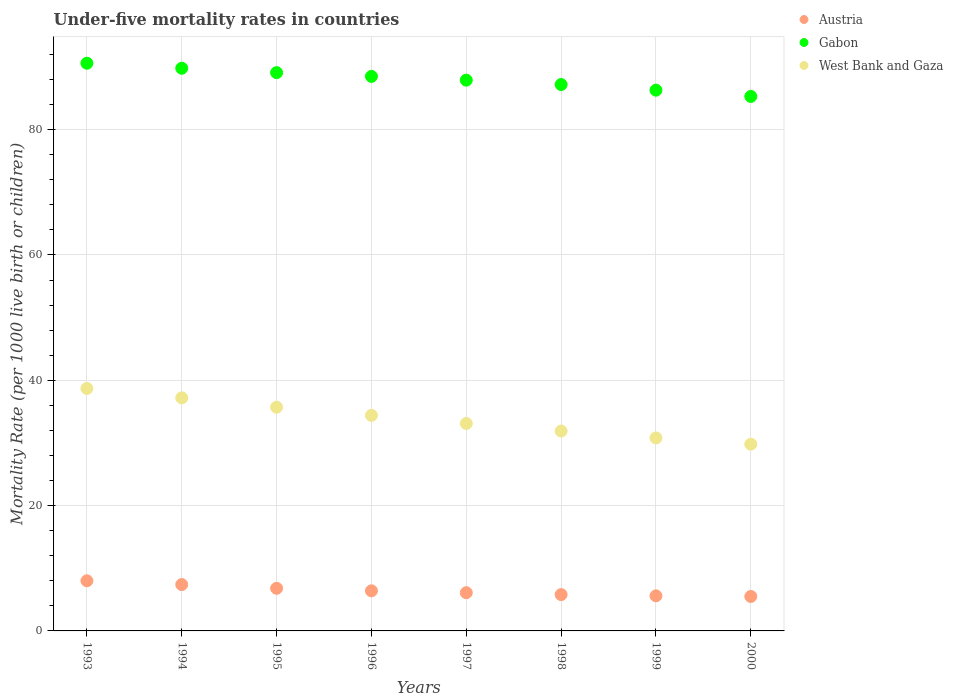How many different coloured dotlines are there?
Provide a succinct answer. 3. What is the under-five mortality rate in Gabon in 1998?
Offer a terse response. 87.2. Across all years, what is the maximum under-five mortality rate in West Bank and Gaza?
Keep it short and to the point. 38.7. Across all years, what is the minimum under-five mortality rate in West Bank and Gaza?
Your answer should be compact. 29.8. In which year was the under-five mortality rate in Austria maximum?
Your answer should be very brief. 1993. In which year was the under-five mortality rate in Austria minimum?
Offer a very short reply. 2000. What is the total under-five mortality rate in Austria in the graph?
Offer a very short reply. 51.6. What is the difference between the under-five mortality rate in West Bank and Gaza in 1994 and that in 2000?
Give a very brief answer. 7.4. What is the difference between the under-five mortality rate in Gabon in 1994 and the under-five mortality rate in Austria in 1999?
Make the answer very short. 84.2. What is the average under-five mortality rate in Austria per year?
Provide a succinct answer. 6.45. In the year 2000, what is the difference between the under-five mortality rate in Austria and under-five mortality rate in West Bank and Gaza?
Provide a succinct answer. -24.3. In how many years, is the under-five mortality rate in Gabon greater than 48?
Give a very brief answer. 8. What is the ratio of the under-five mortality rate in West Bank and Gaza in 1997 to that in 2000?
Keep it short and to the point. 1.11. Is the under-five mortality rate in Gabon in 1993 less than that in 1998?
Offer a very short reply. No. What is the difference between the highest and the second highest under-five mortality rate in West Bank and Gaza?
Your answer should be very brief. 1.5. What is the difference between the highest and the lowest under-five mortality rate in Gabon?
Keep it short and to the point. 5.3. Is it the case that in every year, the sum of the under-five mortality rate in Austria and under-five mortality rate in West Bank and Gaza  is greater than the under-five mortality rate in Gabon?
Provide a short and direct response. No. Does the under-five mortality rate in Gabon monotonically increase over the years?
Offer a terse response. No. Is the under-five mortality rate in Gabon strictly less than the under-five mortality rate in Austria over the years?
Provide a succinct answer. No. How many years are there in the graph?
Your answer should be very brief. 8. Does the graph contain any zero values?
Give a very brief answer. No. Does the graph contain grids?
Offer a very short reply. Yes. Where does the legend appear in the graph?
Provide a succinct answer. Top right. How many legend labels are there?
Your answer should be compact. 3. How are the legend labels stacked?
Give a very brief answer. Vertical. What is the title of the graph?
Keep it short and to the point. Under-five mortality rates in countries. Does "Congo (Republic)" appear as one of the legend labels in the graph?
Keep it short and to the point. No. What is the label or title of the X-axis?
Offer a terse response. Years. What is the label or title of the Y-axis?
Make the answer very short. Mortality Rate (per 1000 live birth or children). What is the Mortality Rate (per 1000 live birth or children) of Gabon in 1993?
Provide a short and direct response. 90.6. What is the Mortality Rate (per 1000 live birth or children) of West Bank and Gaza in 1993?
Offer a very short reply. 38.7. What is the Mortality Rate (per 1000 live birth or children) of Austria in 1994?
Your answer should be very brief. 7.4. What is the Mortality Rate (per 1000 live birth or children) of Gabon in 1994?
Your answer should be very brief. 89.8. What is the Mortality Rate (per 1000 live birth or children) in West Bank and Gaza in 1994?
Provide a short and direct response. 37.2. What is the Mortality Rate (per 1000 live birth or children) in Gabon in 1995?
Your response must be concise. 89.1. What is the Mortality Rate (per 1000 live birth or children) of West Bank and Gaza in 1995?
Provide a succinct answer. 35.7. What is the Mortality Rate (per 1000 live birth or children) of Austria in 1996?
Your answer should be very brief. 6.4. What is the Mortality Rate (per 1000 live birth or children) of Gabon in 1996?
Give a very brief answer. 88.5. What is the Mortality Rate (per 1000 live birth or children) of West Bank and Gaza in 1996?
Offer a very short reply. 34.4. What is the Mortality Rate (per 1000 live birth or children) of Austria in 1997?
Offer a terse response. 6.1. What is the Mortality Rate (per 1000 live birth or children) of Gabon in 1997?
Ensure brevity in your answer.  87.9. What is the Mortality Rate (per 1000 live birth or children) of West Bank and Gaza in 1997?
Give a very brief answer. 33.1. What is the Mortality Rate (per 1000 live birth or children) in Gabon in 1998?
Offer a very short reply. 87.2. What is the Mortality Rate (per 1000 live birth or children) of West Bank and Gaza in 1998?
Your response must be concise. 31.9. What is the Mortality Rate (per 1000 live birth or children) in Gabon in 1999?
Provide a succinct answer. 86.3. What is the Mortality Rate (per 1000 live birth or children) in West Bank and Gaza in 1999?
Keep it short and to the point. 30.8. What is the Mortality Rate (per 1000 live birth or children) in Gabon in 2000?
Make the answer very short. 85.3. What is the Mortality Rate (per 1000 live birth or children) in West Bank and Gaza in 2000?
Your answer should be compact. 29.8. Across all years, what is the maximum Mortality Rate (per 1000 live birth or children) of Austria?
Your answer should be very brief. 8. Across all years, what is the maximum Mortality Rate (per 1000 live birth or children) of Gabon?
Your response must be concise. 90.6. Across all years, what is the maximum Mortality Rate (per 1000 live birth or children) in West Bank and Gaza?
Offer a terse response. 38.7. Across all years, what is the minimum Mortality Rate (per 1000 live birth or children) of Austria?
Provide a succinct answer. 5.5. Across all years, what is the minimum Mortality Rate (per 1000 live birth or children) in Gabon?
Keep it short and to the point. 85.3. Across all years, what is the minimum Mortality Rate (per 1000 live birth or children) in West Bank and Gaza?
Ensure brevity in your answer.  29.8. What is the total Mortality Rate (per 1000 live birth or children) in Austria in the graph?
Keep it short and to the point. 51.6. What is the total Mortality Rate (per 1000 live birth or children) of Gabon in the graph?
Your response must be concise. 704.7. What is the total Mortality Rate (per 1000 live birth or children) in West Bank and Gaza in the graph?
Your answer should be very brief. 271.6. What is the difference between the Mortality Rate (per 1000 live birth or children) of Austria in 1993 and that in 1994?
Give a very brief answer. 0.6. What is the difference between the Mortality Rate (per 1000 live birth or children) in Gabon in 1993 and that in 1994?
Keep it short and to the point. 0.8. What is the difference between the Mortality Rate (per 1000 live birth or children) of West Bank and Gaza in 1993 and that in 1994?
Give a very brief answer. 1.5. What is the difference between the Mortality Rate (per 1000 live birth or children) of Austria in 1993 and that in 1995?
Provide a succinct answer. 1.2. What is the difference between the Mortality Rate (per 1000 live birth or children) in Gabon in 1993 and that in 1995?
Your answer should be very brief. 1.5. What is the difference between the Mortality Rate (per 1000 live birth or children) of Austria in 1993 and that in 1996?
Give a very brief answer. 1.6. What is the difference between the Mortality Rate (per 1000 live birth or children) in West Bank and Gaza in 1993 and that in 1996?
Your answer should be very brief. 4.3. What is the difference between the Mortality Rate (per 1000 live birth or children) in Austria in 1993 and that in 1997?
Make the answer very short. 1.9. What is the difference between the Mortality Rate (per 1000 live birth or children) of West Bank and Gaza in 1993 and that in 1997?
Make the answer very short. 5.6. What is the difference between the Mortality Rate (per 1000 live birth or children) in Austria in 1993 and that in 1998?
Give a very brief answer. 2.2. What is the difference between the Mortality Rate (per 1000 live birth or children) of West Bank and Gaza in 1993 and that in 1998?
Make the answer very short. 6.8. What is the difference between the Mortality Rate (per 1000 live birth or children) of Austria in 1993 and that in 1999?
Your answer should be very brief. 2.4. What is the difference between the Mortality Rate (per 1000 live birth or children) of Gabon in 1993 and that in 1999?
Make the answer very short. 4.3. What is the difference between the Mortality Rate (per 1000 live birth or children) in West Bank and Gaza in 1993 and that in 1999?
Provide a short and direct response. 7.9. What is the difference between the Mortality Rate (per 1000 live birth or children) in Austria in 1993 and that in 2000?
Offer a very short reply. 2.5. What is the difference between the Mortality Rate (per 1000 live birth or children) in Gabon in 1993 and that in 2000?
Make the answer very short. 5.3. What is the difference between the Mortality Rate (per 1000 live birth or children) of West Bank and Gaza in 1993 and that in 2000?
Offer a very short reply. 8.9. What is the difference between the Mortality Rate (per 1000 live birth or children) of Austria in 1994 and that in 1995?
Make the answer very short. 0.6. What is the difference between the Mortality Rate (per 1000 live birth or children) in Gabon in 1994 and that in 1995?
Ensure brevity in your answer.  0.7. What is the difference between the Mortality Rate (per 1000 live birth or children) of Gabon in 1994 and that in 1997?
Keep it short and to the point. 1.9. What is the difference between the Mortality Rate (per 1000 live birth or children) in West Bank and Gaza in 1994 and that in 1997?
Give a very brief answer. 4.1. What is the difference between the Mortality Rate (per 1000 live birth or children) of Gabon in 1994 and that in 1998?
Give a very brief answer. 2.6. What is the difference between the Mortality Rate (per 1000 live birth or children) of West Bank and Gaza in 1994 and that in 1999?
Your response must be concise. 6.4. What is the difference between the Mortality Rate (per 1000 live birth or children) in Gabon in 1994 and that in 2000?
Your answer should be very brief. 4.5. What is the difference between the Mortality Rate (per 1000 live birth or children) of West Bank and Gaza in 1994 and that in 2000?
Give a very brief answer. 7.4. What is the difference between the Mortality Rate (per 1000 live birth or children) in Austria in 1995 and that in 1996?
Your answer should be compact. 0.4. What is the difference between the Mortality Rate (per 1000 live birth or children) of Gabon in 1995 and that in 1996?
Your answer should be very brief. 0.6. What is the difference between the Mortality Rate (per 1000 live birth or children) of West Bank and Gaza in 1995 and that in 1997?
Your response must be concise. 2.6. What is the difference between the Mortality Rate (per 1000 live birth or children) in Gabon in 1995 and that in 1999?
Keep it short and to the point. 2.8. What is the difference between the Mortality Rate (per 1000 live birth or children) in Austria in 1995 and that in 2000?
Your response must be concise. 1.3. What is the difference between the Mortality Rate (per 1000 live birth or children) of West Bank and Gaza in 1995 and that in 2000?
Your answer should be compact. 5.9. What is the difference between the Mortality Rate (per 1000 live birth or children) of Austria in 1996 and that in 1997?
Ensure brevity in your answer.  0.3. What is the difference between the Mortality Rate (per 1000 live birth or children) of Austria in 1996 and that in 1998?
Give a very brief answer. 0.6. What is the difference between the Mortality Rate (per 1000 live birth or children) in Gabon in 1996 and that in 1998?
Your response must be concise. 1.3. What is the difference between the Mortality Rate (per 1000 live birth or children) of Austria in 1996 and that in 1999?
Offer a very short reply. 0.8. What is the difference between the Mortality Rate (per 1000 live birth or children) in West Bank and Gaza in 1996 and that in 1999?
Ensure brevity in your answer.  3.6. What is the difference between the Mortality Rate (per 1000 live birth or children) in Austria in 1996 and that in 2000?
Your answer should be very brief. 0.9. What is the difference between the Mortality Rate (per 1000 live birth or children) of Gabon in 1996 and that in 2000?
Your answer should be compact. 3.2. What is the difference between the Mortality Rate (per 1000 live birth or children) in West Bank and Gaza in 1996 and that in 2000?
Ensure brevity in your answer.  4.6. What is the difference between the Mortality Rate (per 1000 live birth or children) of Gabon in 1997 and that in 1998?
Provide a succinct answer. 0.7. What is the difference between the Mortality Rate (per 1000 live birth or children) of Austria in 1997 and that in 2000?
Provide a short and direct response. 0.6. What is the difference between the Mortality Rate (per 1000 live birth or children) in Gabon in 1998 and that in 1999?
Make the answer very short. 0.9. What is the difference between the Mortality Rate (per 1000 live birth or children) of Gabon in 1998 and that in 2000?
Provide a succinct answer. 1.9. What is the difference between the Mortality Rate (per 1000 live birth or children) of West Bank and Gaza in 1998 and that in 2000?
Offer a very short reply. 2.1. What is the difference between the Mortality Rate (per 1000 live birth or children) of Austria in 1999 and that in 2000?
Keep it short and to the point. 0.1. What is the difference between the Mortality Rate (per 1000 live birth or children) in Gabon in 1999 and that in 2000?
Your answer should be compact. 1. What is the difference between the Mortality Rate (per 1000 live birth or children) in Austria in 1993 and the Mortality Rate (per 1000 live birth or children) in Gabon in 1994?
Your answer should be compact. -81.8. What is the difference between the Mortality Rate (per 1000 live birth or children) in Austria in 1993 and the Mortality Rate (per 1000 live birth or children) in West Bank and Gaza in 1994?
Your answer should be compact. -29.2. What is the difference between the Mortality Rate (per 1000 live birth or children) in Gabon in 1993 and the Mortality Rate (per 1000 live birth or children) in West Bank and Gaza in 1994?
Give a very brief answer. 53.4. What is the difference between the Mortality Rate (per 1000 live birth or children) in Austria in 1993 and the Mortality Rate (per 1000 live birth or children) in Gabon in 1995?
Provide a short and direct response. -81.1. What is the difference between the Mortality Rate (per 1000 live birth or children) in Austria in 1993 and the Mortality Rate (per 1000 live birth or children) in West Bank and Gaza in 1995?
Keep it short and to the point. -27.7. What is the difference between the Mortality Rate (per 1000 live birth or children) of Gabon in 1993 and the Mortality Rate (per 1000 live birth or children) of West Bank and Gaza in 1995?
Offer a terse response. 54.9. What is the difference between the Mortality Rate (per 1000 live birth or children) in Austria in 1993 and the Mortality Rate (per 1000 live birth or children) in Gabon in 1996?
Give a very brief answer. -80.5. What is the difference between the Mortality Rate (per 1000 live birth or children) in Austria in 1993 and the Mortality Rate (per 1000 live birth or children) in West Bank and Gaza in 1996?
Offer a very short reply. -26.4. What is the difference between the Mortality Rate (per 1000 live birth or children) of Gabon in 1993 and the Mortality Rate (per 1000 live birth or children) of West Bank and Gaza in 1996?
Provide a short and direct response. 56.2. What is the difference between the Mortality Rate (per 1000 live birth or children) in Austria in 1993 and the Mortality Rate (per 1000 live birth or children) in Gabon in 1997?
Your answer should be very brief. -79.9. What is the difference between the Mortality Rate (per 1000 live birth or children) in Austria in 1993 and the Mortality Rate (per 1000 live birth or children) in West Bank and Gaza in 1997?
Offer a very short reply. -25.1. What is the difference between the Mortality Rate (per 1000 live birth or children) of Gabon in 1993 and the Mortality Rate (per 1000 live birth or children) of West Bank and Gaza in 1997?
Keep it short and to the point. 57.5. What is the difference between the Mortality Rate (per 1000 live birth or children) in Austria in 1993 and the Mortality Rate (per 1000 live birth or children) in Gabon in 1998?
Make the answer very short. -79.2. What is the difference between the Mortality Rate (per 1000 live birth or children) in Austria in 1993 and the Mortality Rate (per 1000 live birth or children) in West Bank and Gaza in 1998?
Your answer should be compact. -23.9. What is the difference between the Mortality Rate (per 1000 live birth or children) in Gabon in 1993 and the Mortality Rate (per 1000 live birth or children) in West Bank and Gaza in 1998?
Give a very brief answer. 58.7. What is the difference between the Mortality Rate (per 1000 live birth or children) of Austria in 1993 and the Mortality Rate (per 1000 live birth or children) of Gabon in 1999?
Keep it short and to the point. -78.3. What is the difference between the Mortality Rate (per 1000 live birth or children) of Austria in 1993 and the Mortality Rate (per 1000 live birth or children) of West Bank and Gaza in 1999?
Keep it short and to the point. -22.8. What is the difference between the Mortality Rate (per 1000 live birth or children) of Gabon in 1993 and the Mortality Rate (per 1000 live birth or children) of West Bank and Gaza in 1999?
Offer a very short reply. 59.8. What is the difference between the Mortality Rate (per 1000 live birth or children) in Austria in 1993 and the Mortality Rate (per 1000 live birth or children) in Gabon in 2000?
Make the answer very short. -77.3. What is the difference between the Mortality Rate (per 1000 live birth or children) of Austria in 1993 and the Mortality Rate (per 1000 live birth or children) of West Bank and Gaza in 2000?
Your answer should be very brief. -21.8. What is the difference between the Mortality Rate (per 1000 live birth or children) of Gabon in 1993 and the Mortality Rate (per 1000 live birth or children) of West Bank and Gaza in 2000?
Make the answer very short. 60.8. What is the difference between the Mortality Rate (per 1000 live birth or children) in Austria in 1994 and the Mortality Rate (per 1000 live birth or children) in Gabon in 1995?
Your response must be concise. -81.7. What is the difference between the Mortality Rate (per 1000 live birth or children) of Austria in 1994 and the Mortality Rate (per 1000 live birth or children) of West Bank and Gaza in 1995?
Ensure brevity in your answer.  -28.3. What is the difference between the Mortality Rate (per 1000 live birth or children) of Gabon in 1994 and the Mortality Rate (per 1000 live birth or children) of West Bank and Gaza in 1995?
Keep it short and to the point. 54.1. What is the difference between the Mortality Rate (per 1000 live birth or children) of Austria in 1994 and the Mortality Rate (per 1000 live birth or children) of Gabon in 1996?
Your response must be concise. -81.1. What is the difference between the Mortality Rate (per 1000 live birth or children) of Austria in 1994 and the Mortality Rate (per 1000 live birth or children) of West Bank and Gaza in 1996?
Provide a short and direct response. -27. What is the difference between the Mortality Rate (per 1000 live birth or children) of Gabon in 1994 and the Mortality Rate (per 1000 live birth or children) of West Bank and Gaza in 1996?
Offer a very short reply. 55.4. What is the difference between the Mortality Rate (per 1000 live birth or children) of Austria in 1994 and the Mortality Rate (per 1000 live birth or children) of Gabon in 1997?
Provide a succinct answer. -80.5. What is the difference between the Mortality Rate (per 1000 live birth or children) of Austria in 1994 and the Mortality Rate (per 1000 live birth or children) of West Bank and Gaza in 1997?
Offer a very short reply. -25.7. What is the difference between the Mortality Rate (per 1000 live birth or children) in Gabon in 1994 and the Mortality Rate (per 1000 live birth or children) in West Bank and Gaza in 1997?
Offer a terse response. 56.7. What is the difference between the Mortality Rate (per 1000 live birth or children) in Austria in 1994 and the Mortality Rate (per 1000 live birth or children) in Gabon in 1998?
Provide a succinct answer. -79.8. What is the difference between the Mortality Rate (per 1000 live birth or children) in Austria in 1994 and the Mortality Rate (per 1000 live birth or children) in West Bank and Gaza in 1998?
Keep it short and to the point. -24.5. What is the difference between the Mortality Rate (per 1000 live birth or children) of Gabon in 1994 and the Mortality Rate (per 1000 live birth or children) of West Bank and Gaza in 1998?
Your answer should be very brief. 57.9. What is the difference between the Mortality Rate (per 1000 live birth or children) of Austria in 1994 and the Mortality Rate (per 1000 live birth or children) of Gabon in 1999?
Your answer should be very brief. -78.9. What is the difference between the Mortality Rate (per 1000 live birth or children) in Austria in 1994 and the Mortality Rate (per 1000 live birth or children) in West Bank and Gaza in 1999?
Your response must be concise. -23.4. What is the difference between the Mortality Rate (per 1000 live birth or children) of Gabon in 1994 and the Mortality Rate (per 1000 live birth or children) of West Bank and Gaza in 1999?
Your answer should be very brief. 59. What is the difference between the Mortality Rate (per 1000 live birth or children) of Austria in 1994 and the Mortality Rate (per 1000 live birth or children) of Gabon in 2000?
Your response must be concise. -77.9. What is the difference between the Mortality Rate (per 1000 live birth or children) of Austria in 1994 and the Mortality Rate (per 1000 live birth or children) of West Bank and Gaza in 2000?
Your response must be concise. -22.4. What is the difference between the Mortality Rate (per 1000 live birth or children) of Gabon in 1994 and the Mortality Rate (per 1000 live birth or children) of West Bank and Gaza in 2000?
Your answer should be very brief. 60. What is the difference between the Mortality Rate (per 1000 live birth or children) in Austria in 1995 and the Mortality Rate (per 1000 live birth or children) in Gabon in 1996?
Your answer should be compact. -81.7. What is the difference between the Mortality Rate (per 1000 live birth or children) in Austria in 1995 and the Mortality Rate (per 1000 live birth or children) in West Bank and Gaza in 1996?
Provide a succinct answer. -27.6. What is the difference between the Mortality Rate (per 1000 live birth or children) of Gabon in 1995 and the Mortality Rate (per 1000 live birth or children) of West Bank and Gaza in 1996?
Provide a short and direct response. 54.7. What is the difference between the Mortality Rate (per 1000 live birth or children) of Austria in 1995 and the Mortality Rate (per 1000 live birth or children) of Gabon in 1997?
Provide a succinct answer. -81.1. What is the difference between the Mortality Rate (per 1000 live birth or children) in Austria in 1995 and the Mortality Rate (per 1000 live birth or children) in West Bank and Gaza in 1997?
Your answer should be compact. -26.3. What is the difference between the Mortality Rate (per 1000 live birth or children) in Gabon in 1995 and the Mortality Rate (per 1000 live birth or children) in West Bank and Gaza in 1997?
Your answer should be compact. 56. What is the difference between the Mortality Rate (per 1000 live birth or children) of Austria in 1995 and the Mortality Rate (per 1000 live birth or children) of Gabon in 1998?
Give a very brief answer. -80.4. What is the difference between the Mortality Rate (per 1000 live birth or children) in Austria in 1995 and the Mortality Rate (per 1000 live birth or children) in West Bank and Gaza in 1998?
Keep it short and to the point. -25.1. What is the difference between the Mortality Rate (per 1000 live birth or children) of Gabon in 1995 and the Mortality Rate (per 1000 live birth or children) of West Bank and Gaza in 1998?
Your response must be concise. 57.2. What is the difference between the Mortality Rate (per 1000 live birth or children) of Austria in 1995 and the Mortality Rate (per 1000 live birth or children) of Gabon in 1999?
Offer a very short reply. -79.5. What is the difference between the Mortality Rate (per 1000 live birth or children) of Gabon in 1995 and the Mortality Rate (per 1000 live birth or children) of West Bank and Gaza in 1999?
Your answer should be compact. 58.3. What is the difference between the Mortality Rate (per 1000 live birth or children) of Austria in 1995 and the Mortality Rate (per 1000 live birth or children) of Gabon in 2000?
Your answer should be very brief. -78.5. What is the difference between the Mortality Rate (per 1000 live birth or children) of Gabon in 1995 and the Mortality Rate (per 1000 live birth or children) of West Bank and Gaza in 2000?
Provide a short and direct response. 59.3. What is the difference between the Mortality Rate (per 1000 live birth or children) of Austria in 1996 and the Mortality Rate (per 1000 live birth or children) of Gabon in 1997?
Make the answer very short. -81.5. What is the difference between the Mortality Rate (per 1000 live birth or children) in Austria in 1996 and the Mortality Rate (per 1000 live birth or children) in West Bank and Gaza in 1997?
Give a very brief answer. -26.7. What is the difference between the Mortality Rate (per 1000 live birth or children) in Gabon in 1996 and the Mortality Rate (per 1000 live birth or children) in West Bank and Gaza in 1997?
Provide a succinct answer. 55.4. What is the difference between the Mortality Rate (per 1000 live birth or children) of Austria in 1996 and the Mortality Rate (per 1000 live birth or children) of Gabon in 1998?
Your answer should be very brief. -80.8. What is the difference between the Mortality Rate (per 1000 live birth or children) of Austria in 1996 and the Mortality Rate (per 1000 live birth or children) of West Bank and Gaza in 1998?
Give a very brief answer. -25.5. What is the difference between the Mortality Rate (per 1000 live birth or children) in Gabon in 1996 and the Mortality Rate (per 1000 live birth or children) in West Bank and Gaza in 1998?
Your answer should be compact. 56.6. What is the difference between the Mortality Rate (per 1000 live birth or children) of Austria in 1996 and the Mortality Rate (per 1000 live birth or children) of Gabon in 1999?
Your answer should be very brief. -79.9. What is the difference between the Mortality Rate (per 1000 live birth or children) in Austria in 1996 and the Mortality Rate (per 1000 live birth or children) in West Bank and Gaza in 1999?
Keep it short and to the point. -24.4. What is the difference between the Mortality Rate (per 1000 live birth or children) in Gabon in 1996 and the Mortality Rate (per 1000 live birth or children) in West Bank and Gaza in 1999?
Provide a short and direct response. 57.7. What is the difference between the Mortality Rate (per 1000 live birth or children) of Austria in 1996 and the Mortality Rate (per 1000 live birth or children) of Gabon in 2000?
Make the answer very short. -78.9. What is the difference between the Mortality Rate (per 1000 live birth or children) in Austria in 1996 and the Mortality Rate (per 1000 live birth or children) in West Bank and Gaza in 2000?
Make the answer very short. -23.4. What is the difference between the Mortality Rate (per 1000 live birth or children) of Gabon in 1996 and the Mortality Rate (per 1000 live birth or children) of West Bank and Gaza in 2000?
Provide a short and direct response. 58.7. What is the difference between the Mortality Rate (per 1000 live birth or children) of Austria in 1997 and the Mortality Rate (per 1000 live birth or children) of Gabon in 1998?
Offer a very short reply. -81.1. What is the difference between the Mortality Rate (per 1000 live birth or children) of Austria in 1997 and the Mortality Rate (per 1000 live birth or children) of West Bank and Gaza in 1998?
Offer a terse response. -25.8. What is the difference between the Mortality Rate (per 1000 live birth or children) in Gabon in 1997 and the Mortality Rate (per 1000 live birth or children) in West Bank and Gaza in 1998?
Make the answer very short. 56. What is the difference between the Mortality Rate (per 1000 live birth or children) in Austria in 1997 and the Mortality Rate (per 1000 live birth or children) in Gabon in 1999?
Offer a very short reply. -80.2. What is the difference between the Mortality Rate (per 1000 live birth or children) in Austria in 1997 and the Mortality Rate (per 1000 live birth or children) in West Bank and Gaza in 1999?
Make the answer very short. -24.7. What is the difference between the Mortality Rate (per 1000 live birth or children) in Gabon in 1997 and the Mortality Rate (per 1000 live birth or children) in West Bank and Gaza in 1999?
Keep it short and to the point. 57.1. What is the difference between the Mortality Rate (per 1000 live birth or children) of Austria in 1997 and the Mortality Rate (per 1000 live birth or children) of Gabon in 2000?
Make the answer very short. -79.2. What is the difference between the Mortality Rate (per 1000 live birth or children) of Austria in 1997 and the Mortality Rate (per 1000 live birth or children) of West Bank and Gaza in 2000?
Make the answer very short. -23.7. What is the difference between the Mortality Rate (per 1000 live birth or children) in Gabon in 1997 and the Mortality Rate (per 1000 live birth or children) in West Bank and Gaza in 2000?
Your response must be concise. 58.1. What is the difference between the Mortality Rate (per 1000 live birth or children) of Austria in 1998 and the Mortality Rate (per 1000 live birth or children) of Gabon in 1999?
Give a very brief answer. -80.5. What is the difference between the Mortality Rate (per 1000 live birth or children) in Gabon in 1998 and the Mortality Rate (per 1000 live birth or children) in West Bank and Gaza in 1999?
Offer a terse response. 56.4. What is the difference between the Mortality Rate (per 1000 live birth or children) in Austria in 1998 and the Mortality Rate (per 1000 live birth or children) in Gabon in 2000?
Offer a terse response. -79.5. What is the difference between the Mortality Rate (per 1000 live birth or children) in Gabon in 1998 and the Mortality Rate (per 1000 live birth or children) in West Bank and Gaza in 2000?
Give a very brief answer. 57.4. What is the difference between the Mortality Rate (per 1000 live birth or children) in Austria in 1999 and the Mortality Rate (per 1000 live birth or children) in Gabon in 2000?
Keep it short and to the point. -79.7. What is the difference between the Mortality Rate (per 1000 live birth or children) in Austria in 1999 and the Mortality Rate (per 1000 live birth or children) in West Bank and Gaza in 2000?
Provide a short and direct response. -24.2. What is the difference between the Mortality Rate (per 1000 live birth or children) of Gabon in 1999 and the Mortality Rate (per 1000 live birth or children) of West Bank and Gaza in 2000?
Your answer should be compact. 56.5. What is the average Mortality Rate (per 1000 live birth or children) in Austria per year?
Ensure brevity in your answer.  6.45. What is the average Mortality Rate (per 1000 live birth or children) of Gabon per year?
Make the answer very short. 88.09. What is the average Mortality Rate (per 1000 live birth or children) of West Bank and Gaza per year?
Offer a terse response. 33.95. In the year 1993, what is the difference between the Mortality Rate (per 1000 live birth or children) of Austria and Mortality Rate (per 1000 live birth or children) of Gabon?
Ensure brevity in your answer.  -82.6. In the year 1993, what is the difference between the Mortality Rate (per 1000 live birth or children) of Austria and Mortality Rate (per 1000 live birth or children) of West Bank and Gaza?
Make the answer very short. -30.7. In the year 1993, what is the difference between the Mortality Rate (per 1000 live birth or children) in Gabon and Mortality Rate (per 1000 live birth or children) in West Bank and Gaza?
Provide a succinct answer. 51.9. In the year 1994, what is the difference between the Mortality Rate (per 1000 live birth or children) of Austria and Mortality Rate (per 1000 live birth or children) of Gabon?
Offer a very short reply. -82.4. In the year 1994, what is the difference between the Mortality Rate (per 1000 live birth or children) in Austria and Mortality Rate (per 1000 live birth or children) in West Bank and Gaza?
Offer a very short reply. -29.8. In the year 1994, what is the difference between the Mortality Rate (per 1000 live birth or children) of Gabon and Mortality Rate (per 1000 live birth or children) of West Bank and Gaza?
Your answer should be very brief. 52.6. In the year 1995, what is the difference between the Mortality Rate (per 1000 live birth or children) in Austria and Mortality Rate (per 1000 live birth or children) in Gabon?
Your answer should be very brief. -82.3. In the year 1995, what is the difference between the Mortality Rate (per 1000 live birth or children) of Austria and Mortality Rate (per 1000 live birth or children) of West Bank and Gaza?
Your answer should be compact. -28.9. In the year 1995, what is the difference between the Mortality Rate (per 1000 live birth or children) in Gabon and Mortality Rate (per 1000 live birth or children) in West Bank and Gaza?
Your answer should be very brief. 53.4. In the year 1996, what is the difference between the Mortality Rate (per 1000 live birth or children) of Austria and Mortality Rate (per 1000 live birth or children) of Gabon?
Your answer should be compact. -82.1. In the year 1996, what is the difference between the Mortality Rate (per 1000 live birth or children) of Austria and Mortality Rate (per 1000 live birth or children) of West Bank and Gaza?
Make the answer very short. -28. In the year 1996, what is the difference between the Mortality Rate (per 1000 live birth or children) in Gabon and Mortality Rate (per 1000 live birth or children) in West Bank and Gaza?
Provide a short and direct response. 54.1. In the year 1997, what is the difference between the Mortality Rate (per 1000 live birth or children) in Austria and Mortality Rate (per 1000 live birth or children) in Gabon?
Make the answer very short. -81.8. In the year 1997, what is the difference between the Mortality Rate (per 1000 live birth or children) in Gabon and Mortality Rate (per 1000 live birth or children) in West Bank and Gaza?
Make the answer very short. 54.8. In the year 1998, what is the difference between the Mortality Rate (per 1000 live birth or children) of Austria and Mortality Rate (per 1000 live birth or children) of Gabon?
Provide a short and direct response. -81.4. In the year 1998, what is the difference between the Mortality Rate (per 1000 live birth or children) in Austria and Mortality Rate (per 1000 live birth or children) in West Bank and Gaza?
Provide a succinct answer. -26.1. In the year 1998, what is the difference between the Mortality Rate (per 1000 live birth or children) in Gabon and Mortality Rate (per 1000 live birth or children) in West Bank and Gaza?
Make the answer very short. 55.3. In the year 1999, what is the difference between the Mortality Rate (per 1000 live birth or children) in Austria and Mortality Rate (per 1000 live birth or children) in Gabon?
Make the answer very short. -80.7. In the year 1999, what is the difference between the Mortality Rate (per 1000 live birth or children) of Austria and Mortality Rate (per 1000 live birth or children) of West Bank and Gaza?
Keep it short and to the point. -25.2. In the year 1999, what is the difference between the Mortality Rate (per 1000 live birth or children) in Gabon and Mortality Rate (per 1000 live birth or children) in West Bank and Gaza?
Ensure brevity in your answer.  55.5. In the year 2000, what is the difference between the Mortality Rate (per 1000 live birth or children) in Austria and Mortality Rate (per 1000 live birth or children) in Gabon?
Your answer should be compact. -79.8. In the year 2000, what is the difference between the Mortality Rate (per 1000 live birth or children) in Austria and Mortality Rate (per 1000 live birth or children) in West Bank and Gaza?
Your answer should be compact. -24.3. In the year 2000, what is the difference between the Mortality Rate (per 1000 live birth or children) in Gabon and Mortality Rate (per 1000 live birth or children) in West Bank and Gaza?
Your answer should be very brief. 55.5. What is the ratio of the Mortality Rate (per 1000 live birth or children) of Austria in 1993 to that in 1994?
Give a very brief answer. 1.08. What is the ratio of the Mortality Rate (per 1000 live birth or children) of Gabon in 1993 to that in 1994?
Provide a succinct answer. 1.01. What is the ratio of the Mortality Rate (per 1000 live birth or children) of West Bank and Gaza in 1993 to that in 1994?
Keep it short and to the point. 1.04. What is the ratio of the Mortality Rate (per 1000 live birth or children) of Austria in 1993 to that in 1995?
Keep it short and to the point. 1.18. What is the ratio of the Mortality Rate (per 1000 live birth or children) in Gabon in 1993 to that in 1995?
Offer a terse response. 1.02. What is the ratio of the Mortality Rate (per 1000 live birth or children) of West Bank and Gaza in 1993 to that in 1995?
Provide a succinct answer. 1.08. What is the ratio of the Mortality Rate (per 1000 live birth or children) in Austria in 1993 to that in 1996?
Your answer should be very brief. 1.25. What is the ratio of the Mortality Rate (per 1000 live birth or children) of Gabon in 1993 to that in 1996?
Offer a very short reply. 1.02. What is the ratio of the Mortality Rate (per 1000 live birth or children) in West Bank and Gaza in 1993 to that in 1996?
Offer a terse response. 1.12. What is the ratio of the Mortality Rate (per 1000 live birth or children) in Austria in 1993 to that in 1997?
Ensure brevity in your answer.  1.31. What is the ratio of the Mortality Rate (per 1000 live birth or children) in Gabon in 1993 to that in 1997?
Your response must be concise. 1.03. What is the ratio of the Mortality Rate (per 1000 live birth or children) of West Bank and Gaza in 1993 to that in 1997?
Your response must be concise. 1.17. What is the ratio of the Mortality Rate (per 1000 live birth or children) of Austria in 1993 to that in 1998?
Keep it short and to the point. 1.38. What is the ratio of the Mortality Rate (per 1000 live birth or children) in Gabon in 1993 to that in 1998?
Your answer should be very brief. 1.04. What is the ratio of the Mortality Rate (per 1000 live birth or children) in West Bank and Gaza in 1993 to that in 1998?
Offer a terse response. 1.21. What is the ratio of the Mortality Rate (per 1000 live birth or children) of Austria in 1993 to that in 1999?
Your answer should be compact. 1.43. What is the ratio of the Mortality Rate (per 1000 live birth or children) in Gabon in 1993 to that in 1999?
Give a very brief answer. 1.05. What is the ratio of the Mortality Rate (per 1000 live birth or children) of West Bank and Gaza in 1993 to that in 1999?
Offer a very short reply. 1.26. What is the ratio of the Mortality Rate (per 1000 live birth or children) of Austria in 1993 to that in 2000?
Keep it short and to the point. 1.45. What is the ratio of the Mortality Rate (per 1000 live birth or children) in Gabon in 1993 to that in 2000?
Give a very brief answer. 1.06. What is the ratio of the Mortality Rate (per 1000 live birth or children) in West Bank and Gaza in 1993 to that in 2000?
Your answer should be very brief. 1.3. What is the ratio of the Mortality Rate (per 1000 live birth or children) of Austria in 1994 to that in 1995?
Make the answer very short. 1.09. What is the ratio of the Mortality Rate (per 1000 live birth or children) in Gabon in 1994 to that in 1995?
Your answer should be compact. 1.01. What is the ratio of the Mortality Rate (per 1000 live birth or children) of West Bank and Gaza in 1994 to that in 1995?
Offer a terse response. 1.04. What is the ratio of the Mortality Rate (per 1000 live birth or children) of Austria in 1994 to that in 1996?
Ensure brevity in your answer.  1.16. What is the ratio of the Mortality Rate (per 1000 live birth or children) of Gabon in 1994 to that in 1996?
Provide a short and direct response. 1.01. What is the ratio of the Mortality Rate (per 1000 live birth or children) of West Bank and Gaza in 1994 to that in 1996?
Your answer should be compact. 1.08. What is the ratio of the Mortality Rate (per 1000 live birth or children) of Austria in 1994 to that in 1997?
Your answer should be very brief. 1.21. What is the ratio of the Mortality Rate (per 1000 live birth or children) of Gabon in 1994 to that in 1997?
Your answer should be compact. 1.02. What is the ratio of the Mortality Rate (per 1000 live birth or children) of West Bank and Gaza in 1994 to that in 1997?
Keep it short and to the point. 1.12. What is the ratio of the Mortality Rate (per 1000 live birth or children) in Austria in 1994 to that in 1998?
Keep it short and to the point. 1.28. What is the ratio of the Mortality Rate (per 1000 live birth or children) of Gabon in 1994 to that in 1998?
Your answer should be very brief. 1.03. What is the ratio of the Mortality Rate (per 1000 live birth or children) of West Bank and Gaza in 1994 to that in 1998?
Give a very brief answer. 1.17. What is the ratio of the Mortality Rate (per 1000 live birth or children) of Austria in 1994 to that in 1999?
Keep it short and to the point. 1.32. What is the ratio of the Mortality Rate (per 1000 live birth or children) of Gabon in 1994 to that in 1999?
Your answer should be compact. 1.04. What is the ratio of the Mortality Rate (per 1000 live birth or children) in West Bank and Gaza in 1994 to that in 1999?
Provide a succinct answer. 1.21. What is the ratio of the Mortality Rate (per 1000 live birth or children) in Austria in 1994 to that in 2000?
Give a very brief answer. 1.35. What is the ratio of the Mortality Rate (per 1000 live birth or children) of Gabon in 1994 to that in 2000?
Keep it short and to the point. 1.05. What is the ratio of the Mortality Rate (per 1000 live birth or children) in West Bank and Gaza in 1994 to that in 2000?
Your response must be concise. 1.25. What is the ratio of the Mortality Rate (per 1000 live birth or children) of Austria in 1995 to that in 1996?
Provide a short and direct response. 1.06. What is the ratio of the Mortality Rate (per 1000 live birth or children) of Gabon in 1995 to that in 1996?
Give a very brief answer. 1.01. What is the ratio of the Mortality Rate (per 1000 live birth or children) in West Bank and Gaza in 1995 to that in 1996?
Give a very brief answer. 1.04. What is the ratio of the Mortality Rate (per 1000 live birth or children) of Austria in 1995 to that in 1997?
Your response must be concise. 1.11. What is the ratio of the Mortality Rate (per 1000 live birth or children) in Gabon in 1995 to that in 1997?
Ensure brevity in your answer.  1.01. What is the ratio of the Mortality Rate (per 1000 live birth or children) of West Bank and Gaza in 1995 to that in 1997?
Give a very brief answer. 1.08. What is the ratio of the Mortality Rate (per 1000 live birth or children) in Austria in 1995 to that in 1998?
Ensure brevity in your answer.  1.17. What is the ratio of the Mortality Rate (per 1000 live birth or children) in Gabon in 1995 to that in 1998?
Offer a terse response. 1.02. What is the ratio of the Mortality Rate (per 1000 live birth or children) in West Bank and Gaza in 1995 to that in 1998?
Provide a short and direct response. 1.12. What is the ratio of the Mortality Rate (per 1000 live birth or children) of Austria in 1995 to that in 1999?
Provide a short and direct response. 1.21. What is the ratio of the Mortality Rate (per 1000 live birth or children) of Gabon in 1995 to that in 1999?
Your answer should be compact. 1.03. What is the ratio of the Mortality Rate (per 1000 live birth or children) of West Bank and Gaza in 1995 to that in 1999?
Your answer should be compact. 1.16. What is the ratio of the Mortality Rate (per 1000 live birth or children) in Austria in 1995 to that in 2000?
Give a very brief answer. 1.24. What is the ratio of the Mortality Rate (per 1000 live birth or children) of Gabon in 1995 to that in 2000?
Keep it short and to the point. 1.04. What is the ratio of the Mortality Rate (per 1000 live birth or children) in West Bank and Gaza in 1995 to that in 2000?
Give a very brief answer. 1.2. What is the ratio of the Mortality Rate (per 1000 live birth or children) of Austria in 1996 to that in 1997?
Offer a very short reply. 1.05. What is the ratio of the Mortality Rate (per 1000 live birth or children) of Gabon in 1996 to that in 1997?
Provide a succinct answer. 1.01. What is the ratio of the Mortality Rate (per 1000 live birth or children) in West Bank and Gaza in 1996 to that in 1997?
Your answer should be compact. 1.04. What is the ratio of the Mortality Rate (per 1000 live birth or children) in Austria in 1996 to that in 1998?
Your answer should be very brief. 1.1. What is the ratio of the Mortality Rate (per 1000 live birth or children) of Gabon in 1996 to that in 1998?
Ensure brevity in your answer.  1.01. What is the ratio of the Mortality Rate (per 1000 live birth or children) in West Bank and Gaza in 1996 to that in 1998?
Offer a very short reply. 1.08. What is the ratio of the Mortality Rate (per 1000 live birth or children) of Gabon in 1996 to that in 1999?
Keep it short and to the point. 1.03. What is the ratio of the Mortality Rate (per 1000 live birth or children) of West Bank and Gaza in 1996 to that in 1999?
Offer a very short reply. 1.12. What is the ratio of the Mortality Rate (per 1000 live birth or children) of Austria in 1996 to that in 2000?
Your answer should be very brief. 1.16. What is the ratio of the Mortality Rate (per 1000 live birth or children) in Gabon in 1996 to that in 2000?
Ensure brevity in your answer.  1.04. What is the ratio of the Mortality Rate (per 1000 live birth or children) of West Bank and Gaza in 1996 to that in 2000?
Make the answer very short. 1.15. What is the ratio of the Mortality Rate (per 1000 live birth or children) in Austria in 1997 to that in 1998?
Give a very brief answer. 1.05. What is the ratio of the Mortality Rate (per 1000 live birth or children) of Gabon in 1997 to that in 1998?
Provide a succinct answer. 1.01. What is the ratio of the Mortality Rate (per 1000 live birth or children) in West Bank and Gaza in 1997 to that in 1998?
Offer a terse response. 1.04. What is the ratio of the Mortality Rate (per 1000 live birth or children) in Austria in 1997 to that in 1999?
Your answer should be very brief. 1.09. What is the ratio of the Mortality Rate (per 1000 live birth or children) of Gabon in 1997 to that in 1999?
Keep it short and to the point. 1.02. What is the ratio of the Mortality Rate (per 1000 live birth or children) in West Bank and Gaza in 1997 to that in 1999?
Offer a very short reply. 1.07. What is the ratio of the Mortality Rate (per 1000 live birth or children) of Austria in 1997 to that in 2000?
Your response must be concise. 1.11. What is the ratio of the Mortality Rate (per 1000 live birth or children) of Gabon in 1997 to that in 2000?
Give a very brief answer. 1.03. What is the ratio of the Mortality Rate (per 1000 live birth or children) in West Bank and Gaza in 1997 to that in 2000?
Offer a terse response. 1.11. What is the ratio of the Mortality Rate (per 1000 live birth or children) of Austria in 1998 to that in 1999?
Provide a short and direct response. 1.04. What is the ratio of the Mortality Rate (per 1000 live birth or children) in Gabon in 1998 to that in 1999?
Offer a very short reply. 1.01. What is the ratio of the Mortality Rate (per 1000 live birth or children) in West Bank and Gaza in 1998 to that in 1999?
Give a very brief answer. 1.04. What is the ratio of the Mortality Rate (per 1000 live birth or children) of Austria in 1998 to that in 2000?
Keep it short and to the point. 1.05. What is the ratio of the Mortality Rate (per 1000 live birth or children) of Gabon in 1998 to that in 2000?
Keep it short and to the point. 1.02. What is the ratio of the Mortality Rate (per 1000 live birth or children) of West Bank and Gaza in 1998 to that in 2000?
Make the answer very short. 1.07. What is the ratio of the Mortality Rate (per 1000 live birth or children) in Austria in 1999 to that in 2000?
Give a very brief answer. 1.02. What is the ratio of the Mortality Rate (per 1000 live birth or children) in Gabon in 1999 to that in 2000?
Your answer should be compact. 1.01. What is the ratio of the Mortality Rate (per 1000 live birth or children) in West Bank and Gaza in 1999 to that in 2000?
Provide a short and direct response. 1.03. What is the difference between the highest and the second highest Mortality Rate (per 1000 live birth or children) in West Bank and Gaza?
Offer a terse response. 1.5. What is the difference between the highest and the lowest Mortality Rate (per 1000 live birth or children) in Austria?
Ensure brevity in your answer.  2.5. 